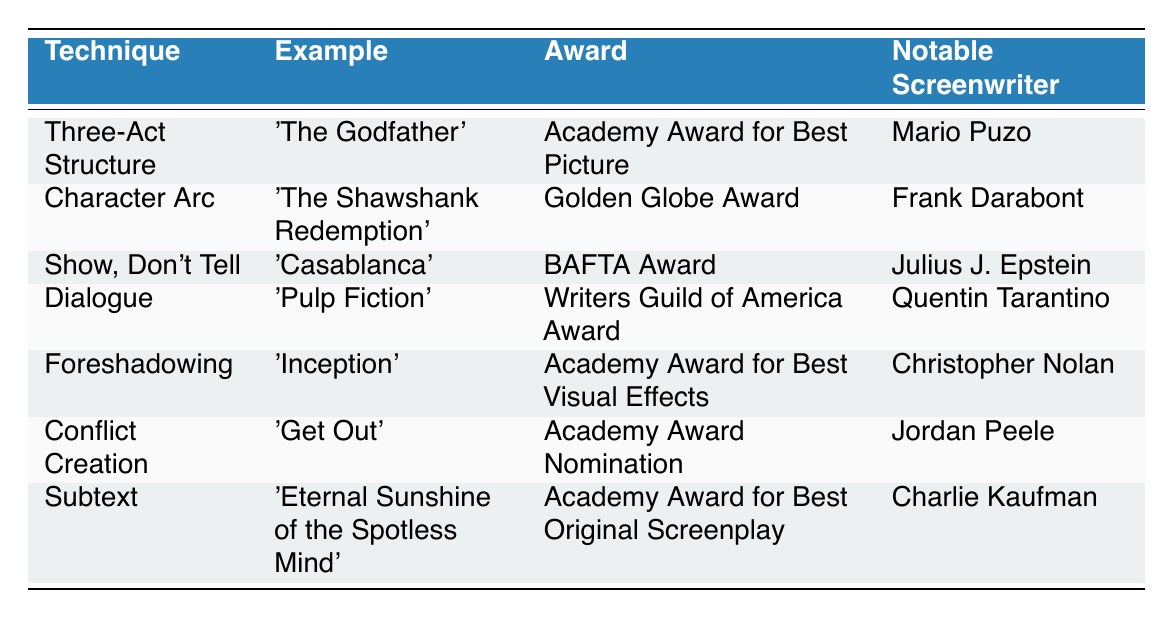What screenplay won the Academy Award for Best Picture? The table lists 'The Godfather' under both the "Example" and "Award" columns for the "Three-Act Structure" technique, indicating it won the Academy Award for Best Picture.
Answer: 'The Godfather' Who is the notable screenwriter for 'Pulp Fiction'? Referring to the table, 'Pulp Fiction' is associated with the "Dialogue" technique, and the notable screenwriter listed for this screenplay is Quentin Tarantino.
Answer: Quentin Tarantino Which technique is associated with the Golden Globe Award? Looking in the "Award" column for the Golden Globe Award, the corresponding "Technique" in the same row is "Character Arc," which is associated with the example 'The Shawshank Redemption'.
Answer: Character Arc How many techniques listed relate to foreshadowing? The term "foreshadowing" appears only once in the table under the technique column associated with 'Inception', indicating it is only related to one instance.
Answer: 1 Did 'Get Out' win an Academy Award? Checking the "Award" column for 'Get Out', it shows "Academy Award Nomination," which means it did not win the award.
Answer: No What is the notable screenwriter for the film that uses the show, don't tell technique? The table shows 'Casablanca' as the example for "Show, Don't Tell," and the notable screenwriter listed is Julius J. Epstein.
Answer: Julius J. Epstein Which technique has the most awards associated with it? By reviewing the table, each technique corresponds to only one award listed, so no technique has more than one associated award.
Answer: None List the screenwriters who have won an Academy Award for Best Screenplay. The table shows 'Eternal Sunshine of the Spotless Mind' won the Academy Award for Best Original Screenplay, with Charlie Kaufman as the screenwriter. However, no other screenwriters are associated with that specific award for screenwriting.
Answer: Charlie Kaufman What award did 'Inception' win? The "Award" column specifies that 'Inception' won the Academy Award for Best Visual Effects, noted in the row under the "Foreshadowing" technique.
Answer: Academy Award for Best Visual Effects Compare the notable screenwriters of the films that used "Conflict Creation" and "Dialogue" techniques. 'Get Out' was written by Jordan Peele under "Conflict Creation" and 'Pulp Fiction' by Quentin Tarantino under "Dialogue." Therefore, comparing these, we see both have different notable screenwriters.
Answer: Jordan Peele and Quentin Tarantino Which technique corresponds to the BAFTA Award? In the "Award" column, the BAFTA Award is linked to "Show, Don't Tell," and the corresponding example is 'Casablanca'.
Answer: Show, Don't Tell 